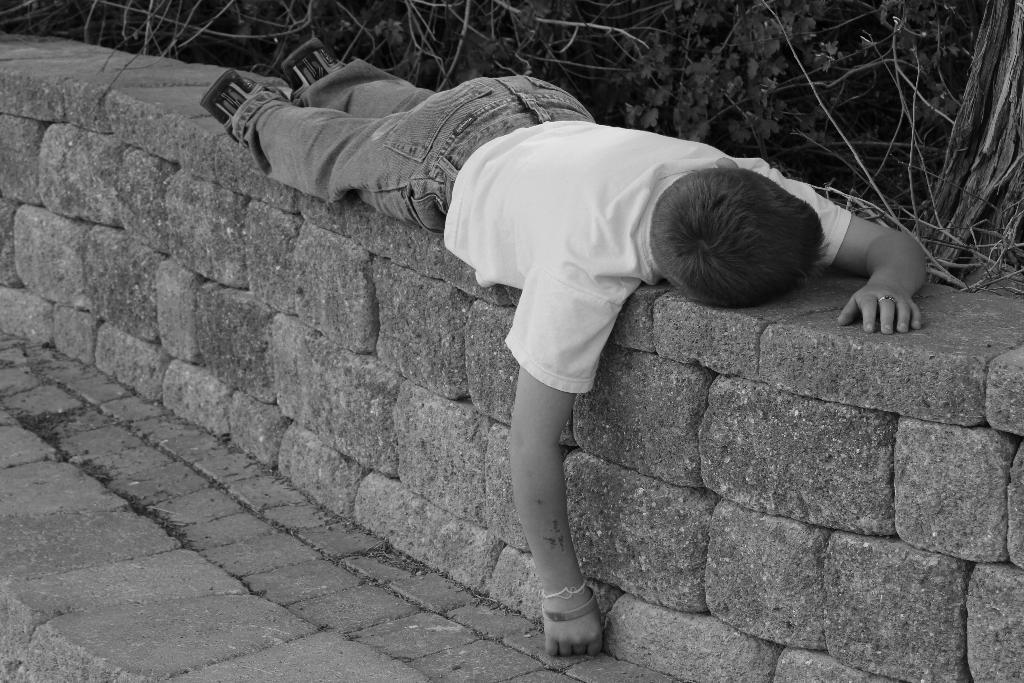What is the person in the image doing? The person is lying on a rock in the image. What is the person wearing? The person is wearing a dress and shoes. What can be seen in the background of the image? There are many trees visible in the image. How does the sink in the image affect the person lying on the rock? There is no sink present in the image, so it cannot affect the person lying on the rock. 